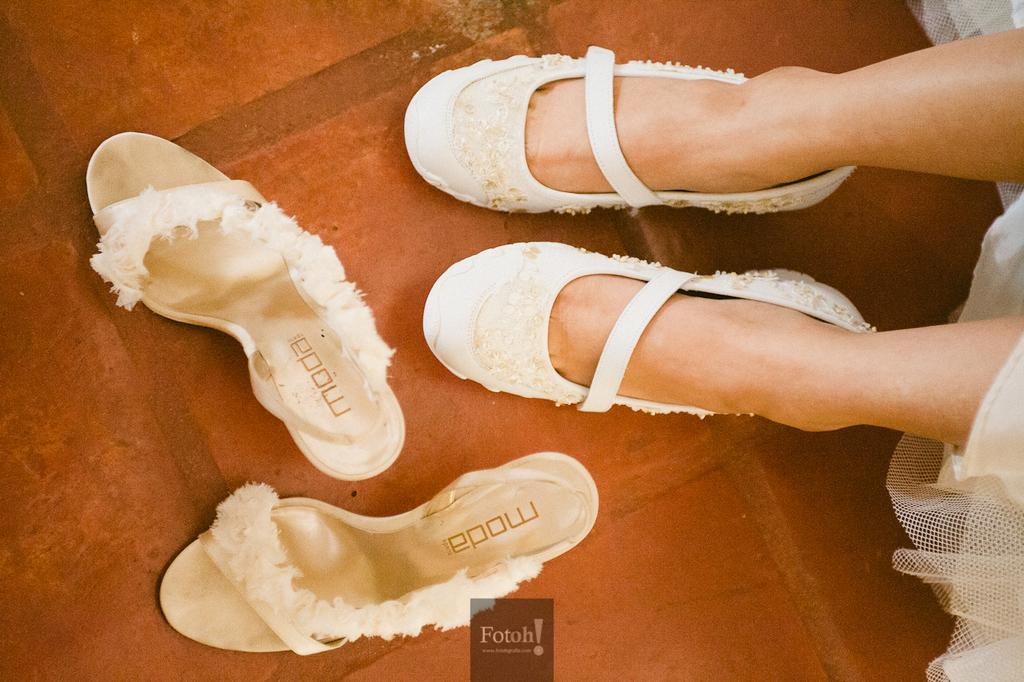What part of a person can be seen in the image? There are legs of a person in the image. What is located on the floor in the image? Foot wears are visible on the floor in the image. What type of bread can be seen on the person's head in the image? There is no bread present in the image, and the person's head is not visible. 